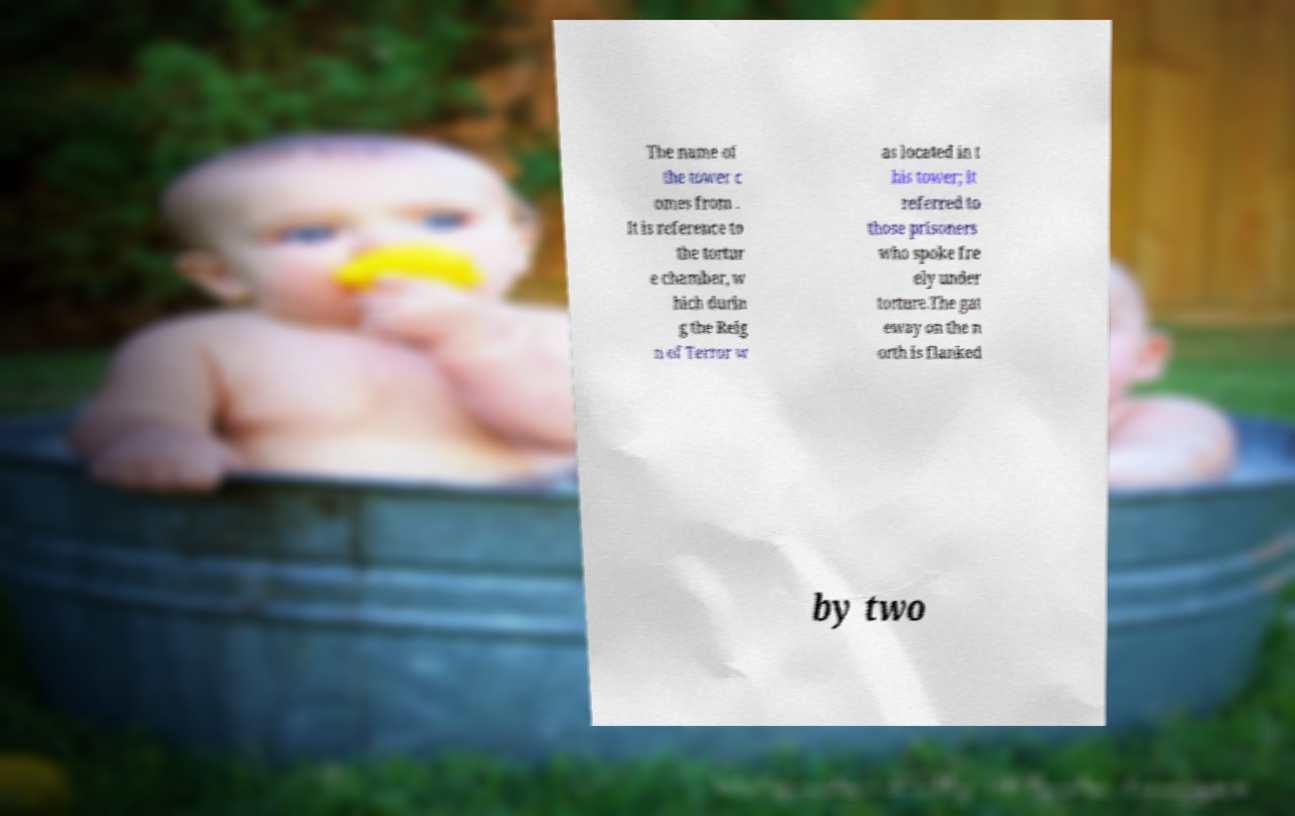Can you read and provide the text displayed in the image?This photo seems to have some interesting text. Can you extract and type it out for me? The name of the tower c omes from . It is reference to the tortur e chamber, w hich durin g the Reig n of Terror w as located in t his tower; it referred to those prisoners who spoke fre ely under torture.The gat eway on the n orth is flanked by two 